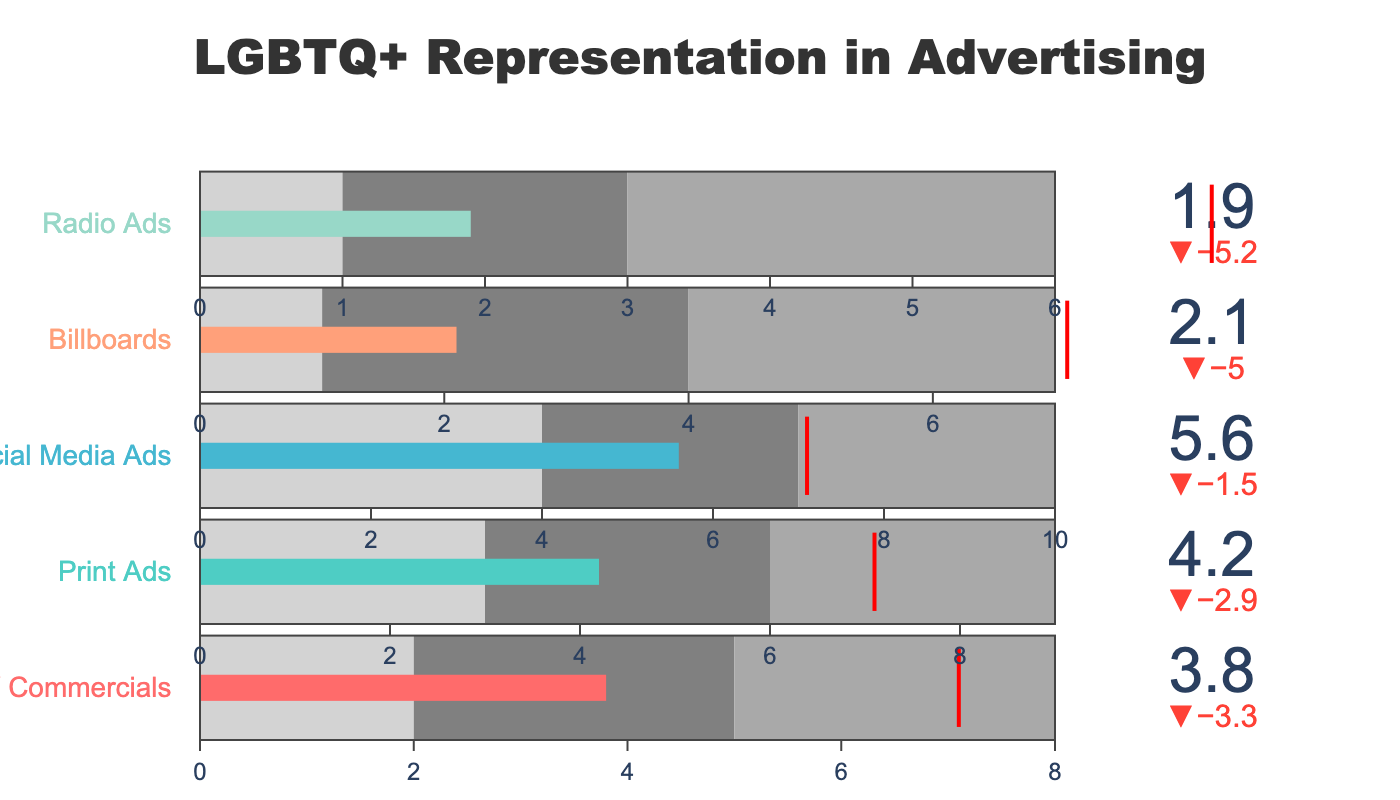What is the title of the figure? The title is usually located at the top of the figure. It is meant to provide an overview of what the chart represents. In this case, the title explicitly states the subject matter.
Answer: LGBTQ+ Representation in Advertising Which advertising category has the lowest actual LGBTQ+ representation? By looking at the length of the bars or the numerical values displayed, we can identify the category with the smallest 'Actual' value.
Answer: Radio Ads How does the actual LGBTQ+ representation in TV Commercials compare to the target? Check the 'Actual' value against the 'Target' value for TV Commercials. The delta indicator will show this difference clearly.
Answer: It is 3.3 less than the target What is the target value for all categories? The target is a consistent numerical goal for each category. As indicated by the red line, we can infer this number.
Answer: 7.1 Which category is closest to its target value? Examine the delta indicators and compare the actual values with their respective targets. Identify the category with the smallest discrepancy.
Answer: Social Media Ads What is the range for the dark gray section in the Social Media Ads bar? Each bullet chart bar has different shades that indicate performance ranges. The dark gray range should be noted.
Answer: 7 to 10 How many categories have an actual representation below 3%? Look at each bar's 'Actual' value and count how many fall below the specified threshold.
Answer: Three (Billboards, Radio Ads, TV Commercials) What is the overall trend in LGBTQ+ representation across the different types of advertising? By reviewing all bars and their relation to their targets, an overall pattern or tendency can be observed.
Answer: Generally, most categories fall short of the 7.1% target Name two categories where the actual representation falls within the gray range but not in the dark gray range. Compare the actual values with the defined ranges. Identify the categories that fit this criteria.
Answer: Print Ads, Billboards Which advertisement type has the second highest actual LGBTQ+ representation? Identify the category with the second largest 'Actual' value after the highest one.
Answer: Print Ads 